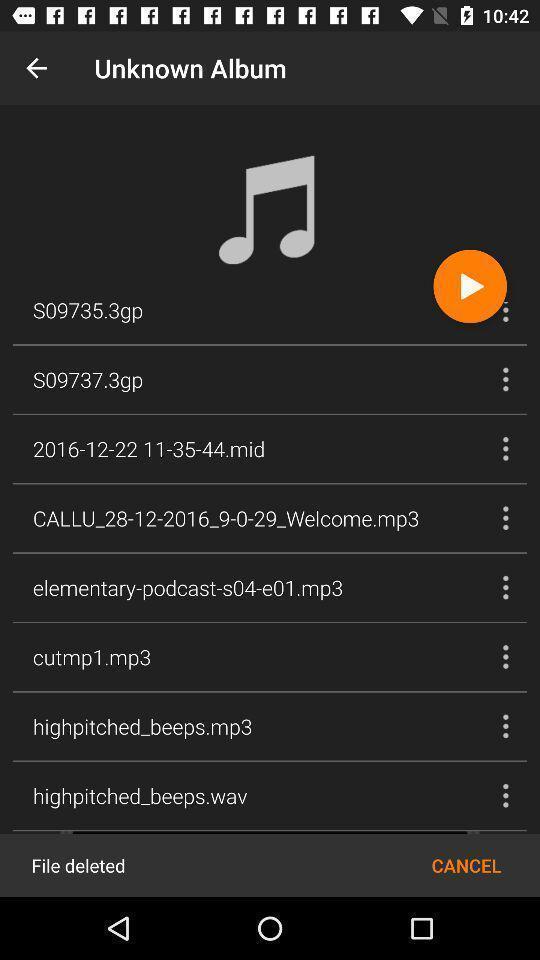Give me a narrative description of this picture. Screen displays different albums. 